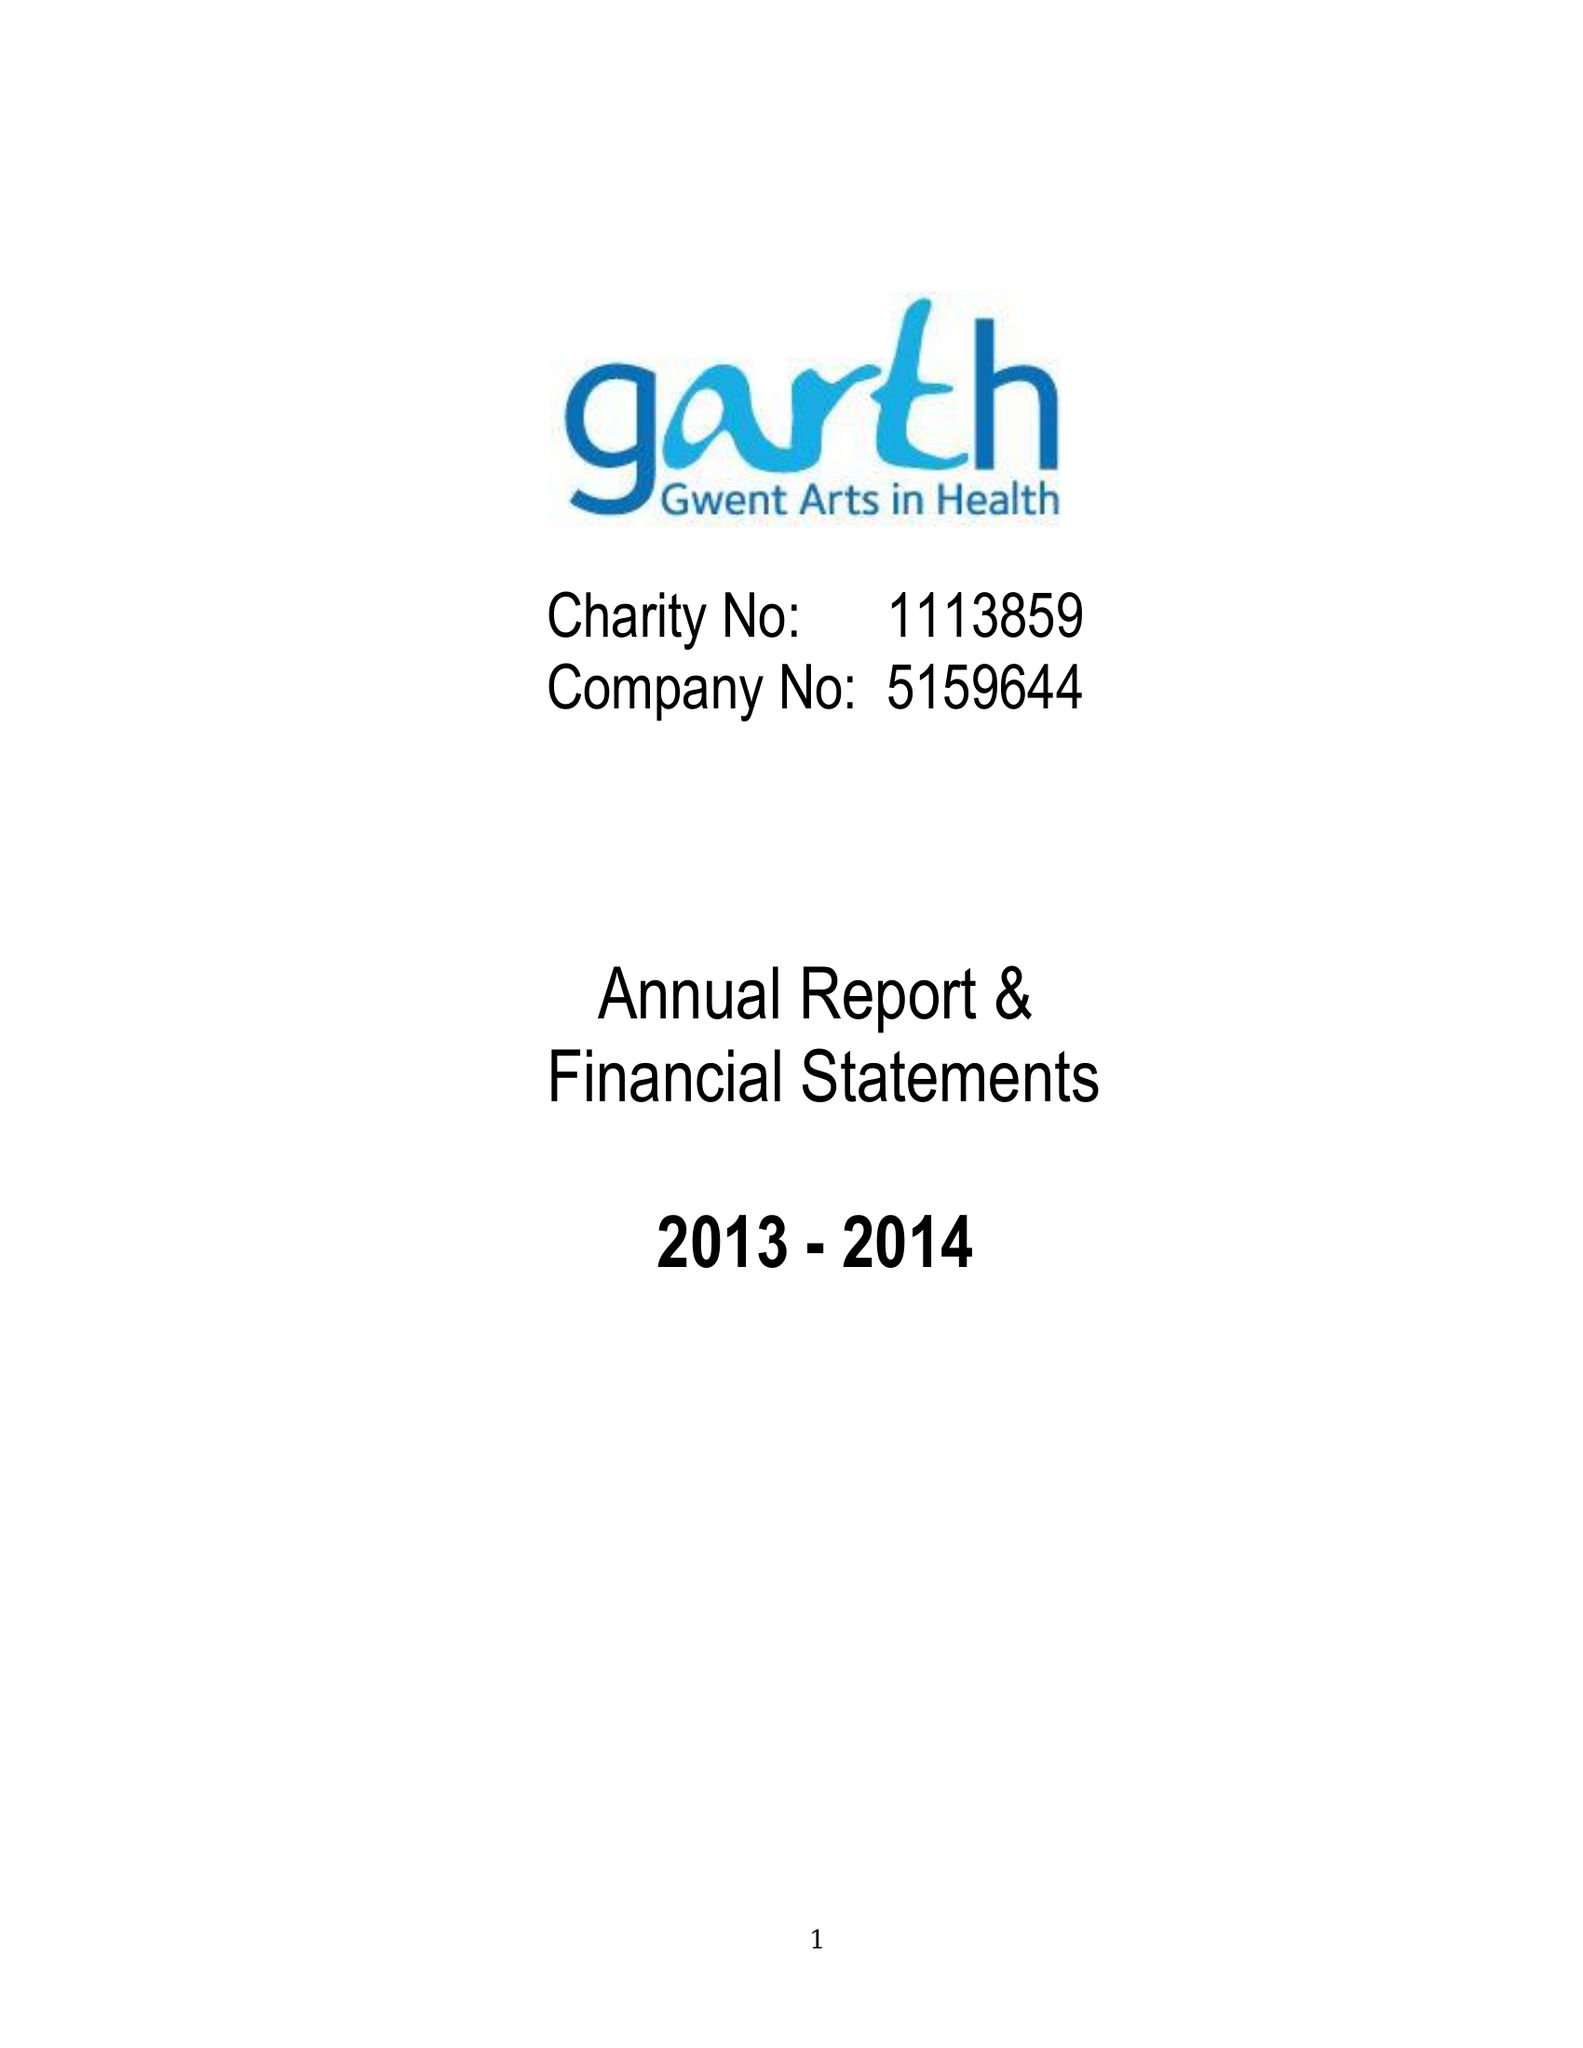What is the value for the income_annually_in_british_pounds?
Answer the question using a single word or phrase. 32541.00 